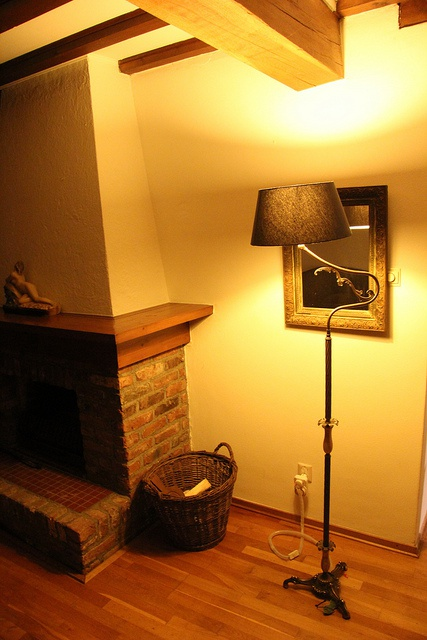Describe the objects in this image and their specific colors. I can see various objects in this image with different colors. 